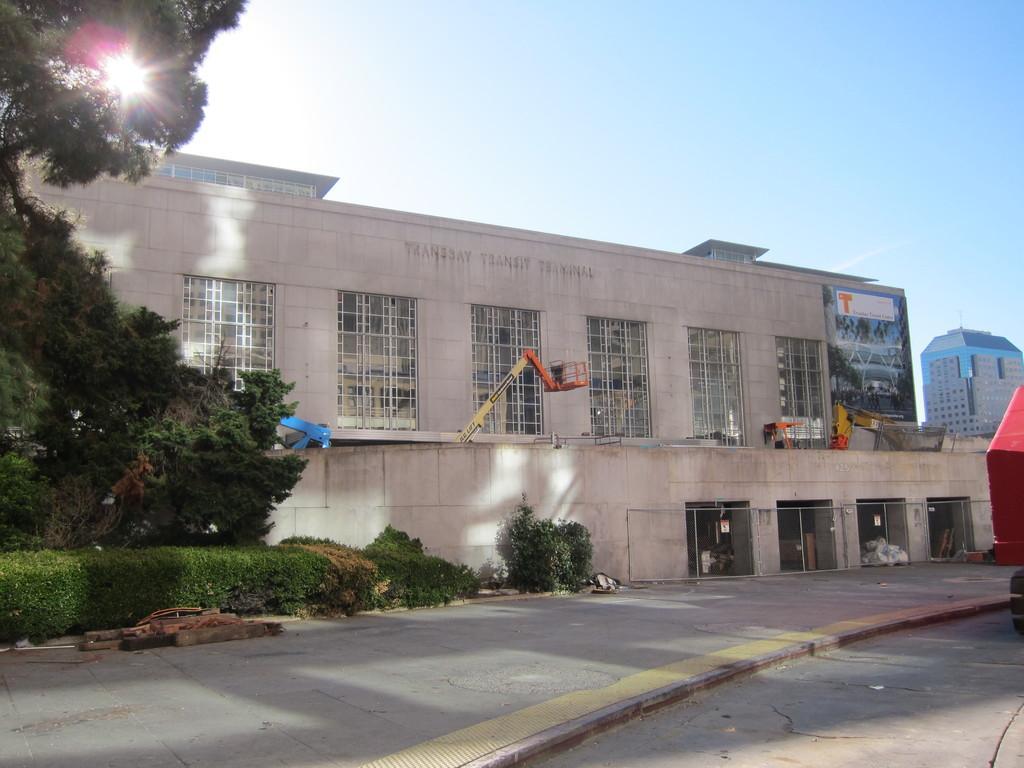Can you describe this image briefly? In this picture I can see buildings and couple of cranes and I can see trees and plants and I can see a blue cloudy sky. 